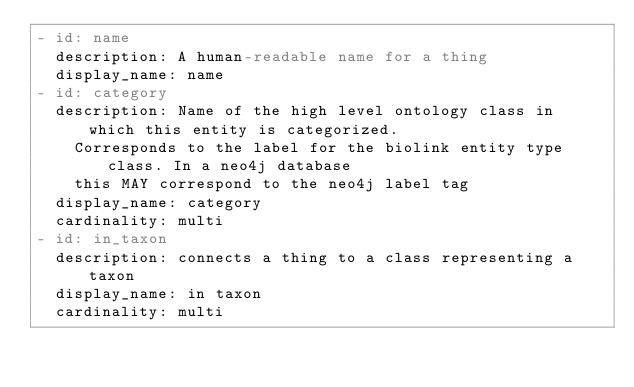<code> <loc_0><loc_0><loc_500><loc_500><_YAML_>- id: name
  description: A human-readable name for a thing
  display_name: name
- id: category
  description: Name of the high level ontology class in which this entity is categorized.
    Corresponds to the label for the biolink entity type class. In a neo4j database
    this MAY correspond to the neo4j label tag
  display_name: category
  cardinality: multi
- id: in_taxon
  description: connects a thing to a class representing a taxon
  display_name: in taxon
  cardinality: multi
</code> 